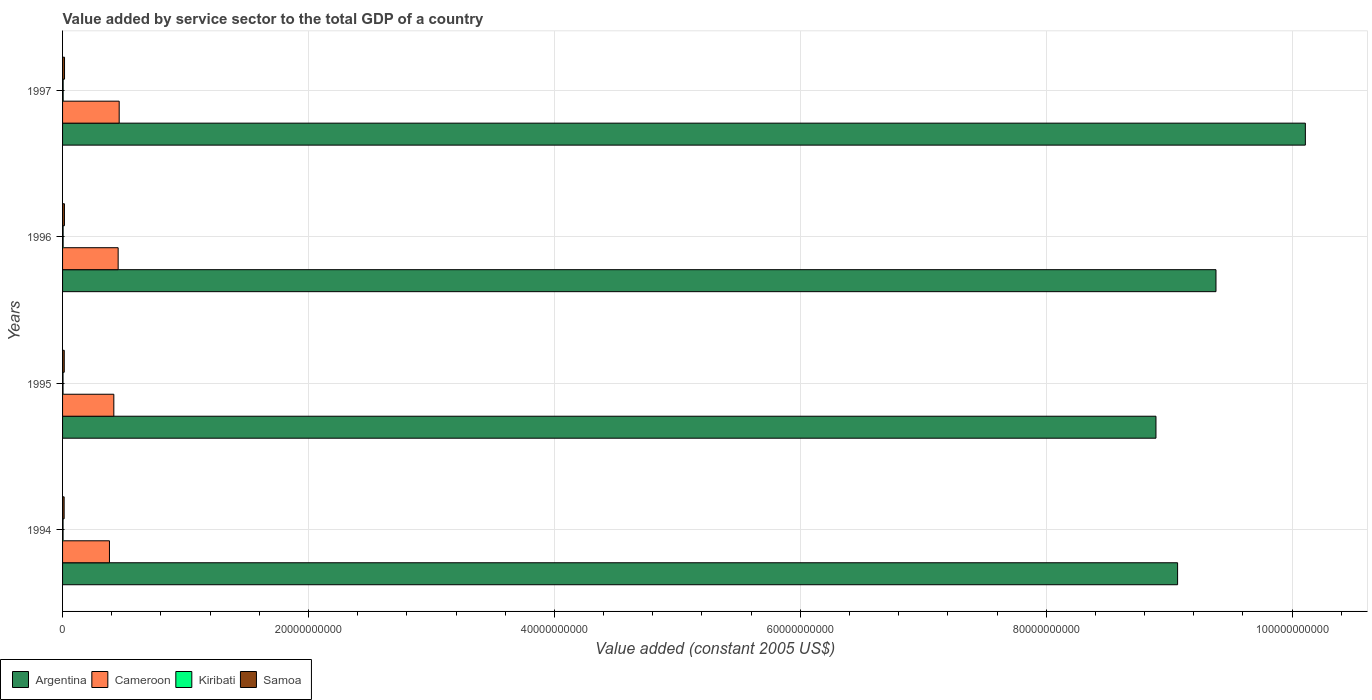Are the number of bars per tick equal to the number of legend labels?
Provide a short and direct response. Yes. How many bars are there on the 2nd tick from the top?
Ensure brevity in your answer.  4. In how many cases, is the number of bars for a given year not equal to the number of legend labels?
Your response must be concise. 0. What is the value added by service sector in Cameroon in 1995?
Give a very brief answer. 4.17e+09. Across all years, what is the maximum value added by service sector in Kiribati?
Offer a terse response. 4.83e+07. Across all years, what is the minimum value added by service sector in Argentina?
Give a very brief answer. 8.89e+1. In which year was the value added by service sector in Kiribati maximum?
Your answer should be compact. 1997. What is the total value added by service sector in Cameroon in the graph?
Offer a very short reply. 1.71e+1. What is the difference between the value added by service sector in Kiribati in 1996 and that in 1997?
Your response must be concise. -3.43e+06. What is the difference between the value added by service sector in Kiribati in 1997 and the value added by service sector in Argentina in 1995?
Your response must be concise. -8.89e+1. What is the average value added by service sector in Kiribati per year?
Offer a very short reply. 4.29e+07. In the year 1994, what is the difference between the value added by service sector in Samoa and value added by service sector in Kiribati?
Ensure brevity in your answer.  8.76e+07. In how many years, is the value added by service sector in Argentina greater than 68000000000 US$?
Offer a very short reply. 4. What is the ratio of the value added by service sector in Cameroon in 1995 to that in 1997?
Provide a succinct answer. 0.91. Is the difference between the value added by service sector in Samoa in 1994 and 1995 greater than the difference between the value added by service sector in Kiribati in 1994 and 1995?
Make the answer very short. No. What is the difference between the highest and the second highest value added by service sector in Samoa?
Offer a very short reply. 8.70e+06. What is the difference between the highest and the lowest value added by service sector in Samoa?
Make the answer very short. 3.19e+07. Is it the case that in every year, the sum of the value added by service sector in Argentina and value added by service sector in Cameroon is greater than the sum of value added by service sector in Samoa and value added by service sector in Kiribati?
Make the answer very short. Yes. What does the 3rd bar from the top in 1997 represents?
Offer a very short reply. Cameroon. What does the 3rd bar from the bottom in 1996 represents?
Your answer should be compact. Kiribati. Is it the case that in every year, the sum of the value added by service sector in Argentina and value added by service sector in Cameroon is greater than the value added by service sector in Kiribati?
Provide a short and direct response. Yes. How many bars are there?
Ensure brevity in your answer.  16. Are all the bars in the graph horizontal?
Provide a succinct answer. Yes. What is the difference between two consecutive major ticks on the X-axis?
Make the answer very short. 2.00e+1. Does the graph contain any zero values?
Provide a succinct answer. No. Does the graph contain grids?
Offer a terse response. Yes. How many legend labels are there?
Offer a very short reply. 4. How are the legend labels stacked?
Your answer should be very brief. Horizontal. What is the title of the graph?
Keep it short and to the point. Value added by service sector to the total GDP of a country. Does "St. Vincent and the Grenadines" appear as one of the legend labels in the graph?
Make the answer very short. No. What is the label or title of the X-axis?
Keep it short and to the point. Value added (constant 2005 US$). What is the label or title of the Y-axis?
Keep it short and to the point. Years. What is the Value added (constant 2005 US$) of Argentina in 1994?
Keep it short and to the point. 9.07e+1. What is the Value added (constant 2005 US$) in Cameroon in 1994?
Give a very brief answer. 3.81e+09. What is the Value added (constant 2005 US$) of Kiribati in 1994?
Provide a succinct answer. 4.09e+07. What is the Value added (constant 2005 US$) of Samoa in 1994?
Your answer should be very brief. 1.29e+08. What is the Value added (constant 2005 US$) in Argentina in 1995?
Keep it short and to the point. 8.89e+1. What is the Value added (constant 2005 US$) of Cameroon in 1995?
Make the answer very short. 4.17e+09. What is the Value added (constant 2005 US$) in Kiribati in 1995?
Make the answer very short. 3.77e+07. What is the Value added (constant 2005 US$) in Samoa in 1995?
Provide a succinct answer. 1.37e+08. What is the Value added (constant 2005 US$) in Argentina in 1996?
Provide a succinct answer. 9.38e+1. What is the Value added (constant 2005 US$) in Cameroon in 1996?
Ensure brevity in your answer.  4.52e+09. What is the Value added (constant 2005 US$) in Kiribati in 1996?
Your answer should be compact. 4.48e+07. What is the Value added (constant 2005 US$) in Samoa in 1996?
Your response must be concise. 1.52e+08. What is the Value added (constant 2005 US$) in Argentina in 1997?
Offer a terse response. 1.01e+11. What is the Value added (constant 2005 US$) in Cameroon in 1997?
Your answer should be very brief. 4.61e+09. What is the Value added (constant 2005 US$) in Kiribati in 1997?
Your response must be concise. 4.83e+07. What is the Value added (constant 2005 US$) of Samoa in 1997?
Your answer should be compact. 1.60e+08. Across all years, what is the maximum Value added (constant 2005 US$) of Argentina?
Ensure brevity in your answer.  1.01e+11. Across all years, what is the maximum Value added (constant 2005 US$) of Cameroon?
Provide a short and direct response. 4.61e+09. Across all years, what is the maximum Value added (constant 2005 US$) of Kiribati?
Provide a short and direct response. 4.83e+07. Across all years, what is the maximum Value added (constant 2005 US$) of Samoa?
Provide a short and direct response. 1.60e+08. Across all years, what is the minimum Value added (constant 2005 US$) in Argentina?
Offer a very short reply. 8.89e+1. Across all years, what is the minimum Value added (constant 2005 US$) in Cameroon?
Ensure brevity in your answer.  3.81e+09. Across all years, what is the minimum Value added (constant 2005 US$) of Kiribati?
Offer a terse response. 3.77e+07. Across all years, what is the minimum Value added (constant 2005 US$) of Samoa?
Keep it short and to the point. 1.29e+08. What is the total Value added (constant 2005 US$) in Argentina in the graph?
Offer a very short reply. 3.74e+11. What is the total Value added (constant 2005 US$) in Cameroon in the graph?
Make the answer very short. 1.71e+1. What is the total Value added (constant 2005 US$) of Kiribati in the graph?
Make the answer very short. 1.72e+08. What is the total Value added (constant 2005 US$) of Samoa in the graph?
Keep it short and to the point. 5.77e+08. What is the difference between the Value added (constant 2005 US$) in Argentina in 1994 and that in 1995?
Ensure brevity in your answer.  1.76e+09. What is the difference between the Value added (constant 2005 US$) of Cameroon in 1994 and that in 1995?
Make the answer very short. -3.55e+08. What is the difference between the Value added (constant 2005 US$) in Kiribati in 1994 and that in 1995?
Your response must be concise. 3.18e+06. What is the difference between the Value added (constant 2005 US$) of Samoa in 1994 and that in 1995?
Your answer should be compact. -8.31e+06. What is the difference between the Value added (constant 2005 US$) in Argentina in 1994 and that in 1996?
Your answer should be compact. -3.12e+09. What is the difference between the Value added (constant 2005 US$) in Cameroon in 1994 and that in 1996?
Provide a short and direct response. -7.07e+08. What is the difference between the Value added (constant 2005 US$) of Kiribati in 1994 and that in 1996?
Provide a succinct answer. -3.93e+06. What is the difference between the Value added (constant 2005 US$) of Samoa in 1994 and that in 1996?
Provide a succinct answer. -2.32e+07. What is the difference between the Value added (constant 2005 US$) in Argentina in 1994 and that in 1997?
Provide a succinct answer. -1.04e+1. What is the difference between the Value added (constant 2005 US$) in Cameroon in 1994 and that in 1997?
Keep it short and to the point. -7.92e+08. What is the difference between the Value added (constant 2005 US$) in Kiribati in 1994 and that in 1997?
Provide a short and direct response. -7.36e+06. What is the difference between the Value added (constant 2005 US$) of Samoa in 1994 and that in 1997?
Your answer should be compact. -3.19e+07. What is the difference between the Value added (constant 2005 US$) of Argentina in 1995 and that in 1996?
Give a very brief answer. -4.88e+09. What is the difference between the Value added (constant 2005 US$) in Cameroon in 1995 and that in 1996?
Your response must be concise. -3.52e+08. What is the difference between the Value added (constant 2005 US$) of Kiribati in 1995 and that in 1996?
Provide a short and direct response. -7.11e+06. What is the difference between the Value added (constant 2005 US$) in Samoa in 1995 and that in 1996?
Your response must be concise. -1.48e+07. What is the difference between the Value added (constant 2005 US$) in Argentina in 1995 and that in 1997?
Your response must be concise. -1.21e+1. What is the difference between the Value added (constant 2005 US$) of Cameroon in 1995 and that in 1997?
Provide a short and direct response. -4.36e+08. What is the difference between the Value added (constant 2005 US$) of Kiribati in 1995 and that in 1997?
Your answer should be compact. -1.05e+07. What is the difference between the Value added (constant 2005 US$) in Samoa in 1995 and that in 1997?
Your response must be concise. -2.35e+07. What is the difference between the Value added (constant 2005 US$) of Argentina in 1996 and that in 1997?
Provide a short and direct response. -7.27e+09. What is the difference between the Value added (constant 2005 US$) in Cameroon in 1996 and that in 1997?
Offer a terse response. -8.45e+07. What is the difference between the Value added (constant 2005 US$) of Kiribati in 1996 and that in 1997?
Provide a succinct answer. -3.43e+06. What is the difference between the Value added (constant 2005 US$) of Samoa in 1996 and that in 1997?
Your response must be concise. -8.70e+06. What is the difference between the Value added (constant 2005 US$) in Argentina in 1994 and the Value added (constant 2005 US$) in Cameroon in 1995?
Keep it short and to the point. 8.65e+1. What is the difference between the Value added (constant 2005 US$) of Argentina in 1994 and the Value added (constant 2005 US$) of Kiribati in 1995?
Make the answer very short. 9.06e+1. What is the difference between the Value added (constant 2005 US$) in Argentina in 1994 and the Value added (constant 2005 US$) in Samoa in 1995?
Make the answer very short. 9.05e+1. What is the difference between the Value added (constant 2005 US$) in Cameroon in 1994 and the Value added (constant 2005 US$) in Kiribati in 1995?
Your answer should be compact. 3.78e+09. What is the difference between the Value added (constant 2005 US$) of Cameroon in 1994 and the Value added (constant 2005 US$) of Samoa in 1995?
Ensure brevity in your answer.  3.68e+09. What is the difference between the Value added (constant 2005 US$) in Kiribati in 1994 and the Value added (constant 2005 US$) in Samoa in 1995?
Your response must be concise. -9.59e+07. What is the difference between the Value added (constant 2005 US$) in Argentina in 1994 and the Value added (constant 2005 US$) in Cameroon in 1996?
Provide a succinct answer. 8.62e+1. What is the difference between the Value added (constant 2005 US$) in Argentina in 1994 and the Value added (constant 2005 US$) in Kiribati in 1996?
Offer a very short reply. 9.06e+1. What is the difference between the Value added (constant 2005 US$) in Argentina in 1994 and the Value added (constant 2005 US$) in Samoa in 1996?
Your answer should be compact. 9.05e+1. What is the difference between the Value added (constant 2005 US$) in Cameroon in 1994 and the Value added (constant 2005 US$) in Kiribati in 1996?
Keep it short and to the point. 3.77e+09. What is the difference between the Value added (constant 2005 US$) in Cameroon in 1994 and the Value added (constant 2005 US$) in Samoa in 1996?
Ensure brevity in your answer.  3.66e+09. What is the difference between the Value added (constant 2005 US$) of Kiribati in 1994 and the Value added (constant 2005 US$) of Samoa in 1996?
Your response must be concise. -1.11e+08. What is the difference between the Value added (constant 2005 US$) in Argentina in 1994 and the Value added (constant 2005 US$) in Cameroon in 1997?
Keep it short and to the point. 8.61e+1. What is the difference between the Value added (constant 2005 US$) in Argentina in 1994 and the Value added (constant 2005 US$) in Kiribati in 1997?
Your answer should be compact. 9.06e+1. What is the difference between the Value added (constant 2005 US$) of Argentina in 1994 and the Value added (constant 2005 US$) of Samoa in 1997?
Keep it short and to the point. 9.05e+1. What is the difference between the Value added (constant 2005 US$) of Cameroon in 1994 and the Value added (constant 2005 US$) of Kiribati in 1997?
Offer a very short reply. 3.77e+09. What is the difference between the Value added (constant 2005 US$) in Cameroon in 1994 and the Value added (constant 2005 US$) in Samoa in 1997?
Provide a short and direct response. 3.65e+09. What is the difference between the Value added (constant 2005 US$) in Kiribati in 1994 and the Value added (constant 2005 US$) in Samoa in 1997?
Your response must be concise. -1.19e+08. What is the difference between the Value added (constant 2005 US$) of Argentina in 1995 and the Value added (constant 2005 US$) of Cameroon in 1996?
Provide a short and direct response. 8.44e+1. What is the difference between the Value added (constant 2005 US$) of Argentina in 1995 and the Value added (constant 2005 US$) of Kiribati in 1996?
Offer a very short reply. 8.89e+1. What is the difference between the Value added (constant 2005 US$) of Argentina in 1995 and the Value added (constant 2005 US$) of Samoa in 1996?
Ensure brevity in your answer.  8.88e+1. What is the difference between the Value added (constant 2005 US$) in Cameroon in 1995 and the Value added (constant 2005 US$) in Kiribati in 1996?
Your answer should be compact. 4.12e+09. What is the difference between the Value added (constant 2005 US$) in Cameroon in 1995 and the Value added (constant 2005 US$) in Samoa in 1996?
Your answer should be compact. 4.02e+09. What is the difference between the Value added (constant 2005 US$) of Kiribati in 1995 and the Value added (constant 2005 US$) of Samoa in 1996?
Your answer should be compact. -1.14e+08. What is the difference between the Value added (constant 2005 US$) of Argentina in 1995 and the Value added (constant 2005 US$) of Cameroon in 1997?
Your response must be concise. 8.43e+1. What is the difference between the Value added (constant 2005 US$) in Argentina in 1995 and the Value added (constant 2005 US$) in Kiribati in 1997?
Provide a short and direct response. 8.89e+1. What is the difference between the Value added (constant 2005 US$) in Argentina in 1995 and the Value added (constant 2005 US$) in Samoa in 1997?
Ensure brevity in your answer.  8.88e+1. What is the difference between the Value added (constant 2005 US$) of Cameroon in 1995 and the Value added (constant 2005 US$) of Kiribati in 1997?
Offer a very short reply. 4.12e+09. What is the difference between the Value added (constant 2005 US$) in Cameroon in 1995 and the Value added (constant 2005 US$) in Samoa in 1997?
Make the answer very short. 4.01e+09. What is the difference between the Value added (constant 2005 US$) in Kiribati in 1995 and the Value added (constant 2005 US$) in Samoa in 1997?
Give a very brief answer. -1.23e+08. What is the difference between the Value added (constant 2005 US$) of Argentina in 1996 and the Value added (constant 2005 US$) of Cameroon in 1997?
Provide a short and direct response. 8.92e+1. What is the difference between the Value added (constant 2005 US$) of Argentina in 1996 and the Value added (constant 2005 US$) of Kiribati in 1997?
Your answer should be very brief. 9.38e+1. What is the difference between the Value added (constant 2005 US$) of Argentina in 1996 and the Value added (constant 2005 US$) of Samoa in 1997?
Provide a short and direct response. 9.36e+1. What is the difference between the Value added (constant 2005 US$) in Cameroon in 1996 and the Value added (constant 2005 US$) in Kiribati in 1997?
Offer a terse response. 4.47e+09. What is the difference between the Value added (constant 2005 US$) in Cameroon in 1996 and the Value added (constant 2005 US$) in Samoa in 1997?
Provide a short and direct response. 4.36e+09. What is the difference between the Value added (constant 2005 US$) in Kiribati in 1996 and the Value added (constant 2005 US$) in Samoa in 1997?
Your response must be concise. -1.16e+08. What is the average Value added (constant 2005 US$) of Argentina per year?
Ensure brevity in your answer.  9.36e+1. What is the average Value added (constant 2005 US$) of Cameroon per year?
Keep it short and to the point. 4.28e+09. What is the average Value added (constant 2005 US$) in Kiribati per year?
Your answer should be compact. 4.29e+07. What is the average Value added (constant 2005 US$) of Samoa per year?
Offer a terse response. 1.44e+08. In the year 1994, what is the difference between the Value added (constant 2005 US$) of Argentina and Value added (constant 2005 US$) of Cameroon?
Offer a terse response. 8.69e+1. In the year 1994, what is the difference between the Value added (constant 2005 US$) in Argentina and Value added (constant 2005 US$) in Kiribati?
Make the answer very short. 9.06e+1. In the year 1994, what is the difference between the Value added (constant 2005 US$) of Argentina and Value added (constant 2005 US$) of Samoa?
Provide a succinct answer. 9.06e+1. In the year 1994, what is the difference between the Value added (constant 2005 US$) in Cameroon and Value added (constant 2005 US$) in Kiribati?
Your answer should be very brief. 3.77e+09. In the year 1994, what is the difference between the Value added (constant 2005 US$) of Cameroon and Value added (constant 2005 US$) of Samoa?
Your answer should be very brief. 3.69e+09. In the year 1994, what is the difference between the Value added (constant 2005 US$) in Kiribati and Value added (constant 2005 US$) in Samoa?
Provide a succinct answer. -8.76e+07. In the year 1995, what is the difference between the Value added (constant 2005 US$) of Argentina and Value added (constant 2005 US$) of Cameroon?
Keep it short and to the point. 8.48e+1. In the year 1995, what is the difference between the Value added (constant 2005 US$) of Argentina and Value added (constant 2005 US$) of Kiribati?
Keep it short and to the point. 8.89e+1. In the year 1995, what is the difference between the Value added (constant 2005 US$) of Argentina and Value added (constant 2005 US$) of Samoa?
Provide a succinct answer. 8.88e+1. In the year 1995, what is the difference between the Value added (constant 2005 US$) of Cameroon and Value added (constant 2005 US$) of Kiribati?
Make the answer very short. 4.13e+09. In the year 1995, what is the difference between the Value added (constant 2005 US$) of Cameroon and Value added (constant 2005 US$) of Samoa?
Offer a terse response. 4.03e+09. In the year 1995, what is the difference between the Value added (constant 2005 US$) in Kiribati and Value added (constant 2005 US$) in Samoa?
Offer a terse response. -9.91e+07. In the year 1996, what is the difference between the Value added (constant 2005 US$) in Argentina and Value added (constant 2005 US$) in Cameroon?
Keep it short and to the point. 8.93e+1. In the year 1996, what is the difference between the Value added (constant 2005 US$) of Argentina and Value added (constant 2005 US$) of Kiribati?
Your answer should be very brief. 9.38e+1. In the year 1996, what is the difference between the Value added (constant 2005 US$) of Argentina and Value added (constant 2005 US$) of Samoa?
Provide a short and direct response. 9.37e+1. In the year 1996, what is the difference between the Value added (constant 2005 US$) in Cameroon and Value added (constant 2005 US$) in Kiribati?
Ensure brevity in your answer.  4.48e+09. In the year 1996, what is the difference between the Value added (constant 2005 US$) in Cameroon and Value added (constant 2005 US$) in Samoa?
Ensure brevity in your answer.  4.37e+09. In the year 1996, what is the difference between the Value added (constant 2005 US$) in Kiribati and Value added (constant 2005 US$) in Samoa?
Your answer should be very brief. -1.07e+08. In the year 1997, what is the difference between the Value added (constant 2005 US$) in Argentina and Value added (constant 2005 US$) in Cameroon?
Your response must be concise. 9.65e+1. In the year 1997, what is the difference between the Value added (constant 2005 US$) in Argentina and Value added (constant 2005 US$) in Kiribati?
Your response must be concise. 1.01e+11. In the year 1997, what is the difference between the Value added (constant 2005 US$) in Argentina and Value added (constant 2005 US$) in Samoa?
Give a very brief answer. 1.01e+11. In the year 1997, what is the difference between the Value added (constant 2005 US$) of Cameroon and Value added (constant 2005 US$) of Kiribati?
Give a very brief answer. 4.56e+09. In the year 1997, what is the difference between the Value added (constant 2005 US$) of Cameroon and Value added (constant 2005 US$) of Samoa?
Your answer should be compact. 4.45e+09. In the year 1997, what is the difference between the Value added (constant 2005 US$) of Kiribati and Value added (constant 2005 US$) of Samoa?
Provide a succinct answer. -1.12e+08. What is the ratio of the Value added (constant 2005 US$) of Argentina in 1994 to that in 1995?
Provide a succinct answer. 1.02. What is the ratio of the Value added (constant 2005 US$) in Cameroon in 1994 to that in 1995?
Provide a succinct answer. 0.91. What is the ratio of the Value added (constant 2005 US$) of Kiribati in 1994 to that in 1995?
Your answer should be very brief. 1.08. What is the ratio of the Value added (constant 2005 US$) in Samoa in 1994 to that in 1995?
Your response must be concise. 0.94. What is the ratio of the Value added (constant 2005 US$) in Argentina in 1994 to that in 1996?
Your response must be concise. 0.97. What is the ratio of the Value added (constant 2005 US$) of Cameroon in 1994 to that in 1996?
Offer a very short reply. 0.84. What is the ratio of the Value added (constant 2005 US$) in Kiribati in 1994 to that in 1996?
Your answer should be compact. 0.91. What is the ratio of the Value added (constant 2005 US$) in Samoa in 1994 to that in 1996?
Offer a very short reply. 0.85. What is the ratio of the Value added (constant 2005 US$) in Argentina in 1994 to that in 1997?
Provide a short and direct response. 0.9. What is the ratio of the Value added (constant 2005 US$) of Cameroon in 1994 to that in 1997?
Give a very brief answer. 0.83. What is the ratio of the Value added (constant 2005 US$) of Kiribati in 1994 to that in 1997?
Ensure brevity in your answer.  0.85. What is the ratio of the Value added (constant 2005 US$) of Samoa in 1994 to that in 1997?
Your answer should be compact. 0.8. What is the ratio of the Value added (constant 2005 US$) in Argentina in 1995 to that in 1996?
Your answer should be very brief. 0.95. What is the ratio of the Value added (constant 2005 US$) of Cameroon in 1995 to that in 1996?
Your answer should be compact. 0.92. What is the ratio of the Value added (constant 2005 US$) in Kiribati in 1995 to that in 1996?
Your answer should be compact. 0.84. What is the ratio of the Value added (constant 2005 US$) of Samoa in 1995 to that in 1996?
Offer a terse response. 0.9. What is the ratio of the Value added (constant 2005 US$) in Argentina in 1995 to that in 1997?
Provide a succinct answer. 0.88. What is the ratio of the Value added (constant 2005 US$) of Cameroon in 1995 to that in 1997?
Give a very brief answer. 0.91. What is the ratio of the Value added (constant 2005 US$) of Kiribati in 1995 to that in 1997?
Your answer should be compact. 0.78. What is the ratio of the Value added (constant 2005 US$) in Samoa in 1995 to that in 1997?
Offer a very short reply. 0.85. What is the ratio of the Value added (constant 2005 US$) of Argentina in 1996 to that in 1997?
Give a very brief answer. 0.93. What is the ratio of the Value added (constant 2005 US$) of Cameroon in 1996 to that in 1997?
Your answer should be very brief. 0.98. What is the ratio of the Value added (constant 2005 US$) of Kiribati in 1996 to that in 1997?
Your answer should be compact. 0.93. What is the ratio of the Value added (constant 2005 US$) in Samoa in 1996 to that in 1997?
Provide a succinct answer. 0.95. What is the difference between the highest and the second highest Value added (constant 2005 US$) of Argentina?
Make the answer very short. 7.27e+09. What is the difference between the highest and the second highest Value added (constant 2005 US$) in Cameroon?
Ensure brevity in your answer.  8.45e+07. What is the difference between the highest and the second highest Value added (constant 2005 US$) in Kiribati?
Make the answer very short. 3.43e+06. What is the difference between the highest and the second highest Value added (constant 2005 US$) in Samoa?
Keep it short and to the point. 8.70e+06. What is the difference between the highest and the lowest Value added (constant 2005 US$) of Argentina?
Offer a very short reply. 1.21e+1. What is the difference between the highest and the lowest Value added (constant 2005 US$) of Cameroon?
Make the answer very short. 7.92e+08. What is the difference between the highest and the lowest Value added (constant 2005 US$) of Kiribati?
Provide a succinct answer. 1.05e+07. What is the difference between the highest and the lowest Value added (constant 2005 US$) in Samoa?
Your answer should be compact. 3.19e+07. 